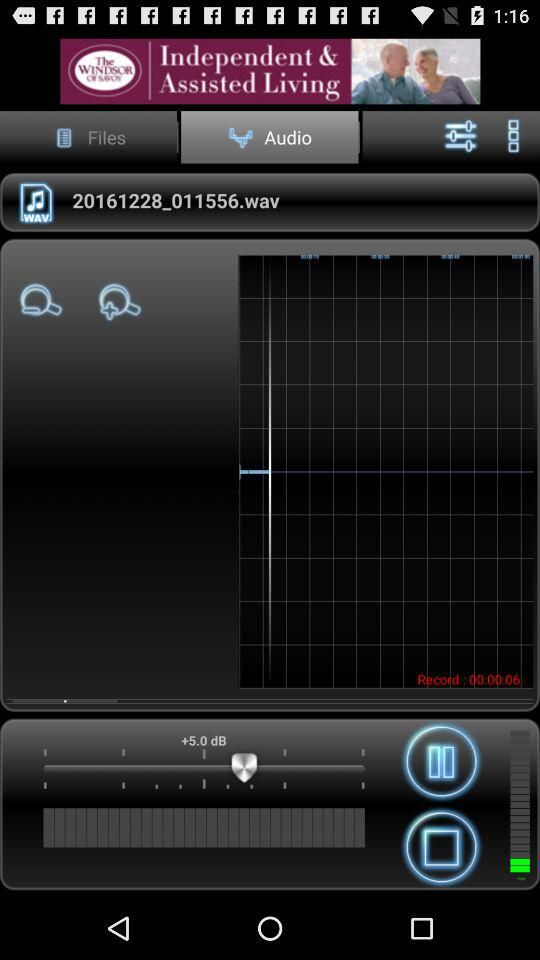Which tab is selected? The selected tab is "Audio". 